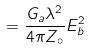Convert formula to latex. <formula><loc_0><loc_0><loc_500><loc_500>= \frac { G _ { a } \lambda ^ { 2 } } { 4 \pi Z _ { \circ } } E _ { b } ^ { 2 }</formula> 